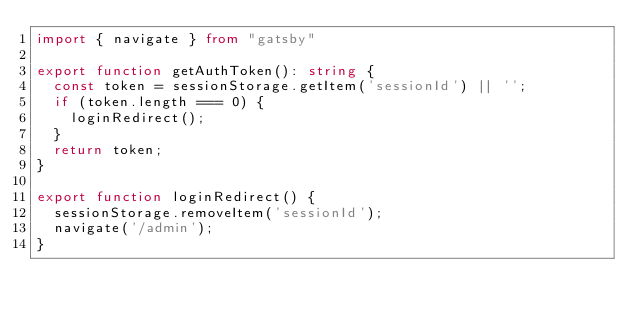<code> <loc_0><loc_0><loc_500><loc_500><_TypeScript_>import { navigate } from "gatsby"

export function getAuthToken(): string {
	const token = sessionStorage.getItem('sessionId') || '';
	if (token.length === 0) {
		loginRedirect();
	}
	return token;
}

export function loginRedirect() {
	sessionStorage.removeItem('sessionId');
	navigate('/admin');
}</code> 